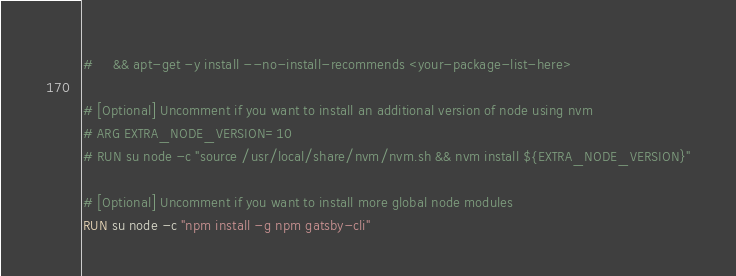<code> <loc_0><loc_0><loc_500><loc_500><_Dockerfile_>#     && apt-get -y install --no-install-recommends <your-package-list-here>

# [Optional] Uncomment if you want to install an additional version of node using nvm
# ARG EXTRA_NODE_VERSION=10
# RUN su node -c "source /usr/local/share/nvm/nvm.sh && nvm install ${EXTRA_NODE_VERSION}"

# [Optional] Uncomment if you want to install more global node modules
RUN su node -c "npm install -g npm gatsby-cli"
</code> 